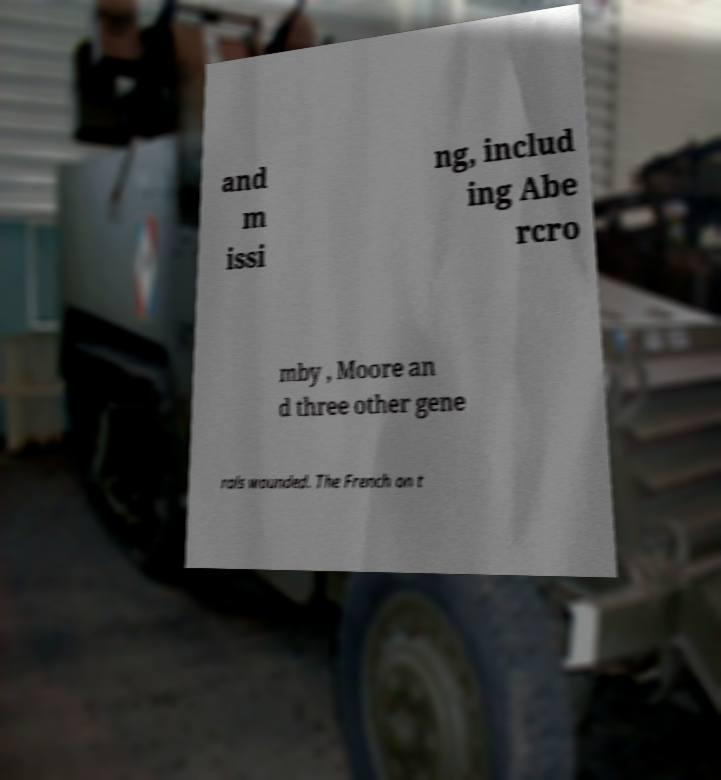Please identify and transcribe the text found in this image. and m issi ng, includ ing Abe rcro mby , Moore an d three other gene rals wounded. The French on t 